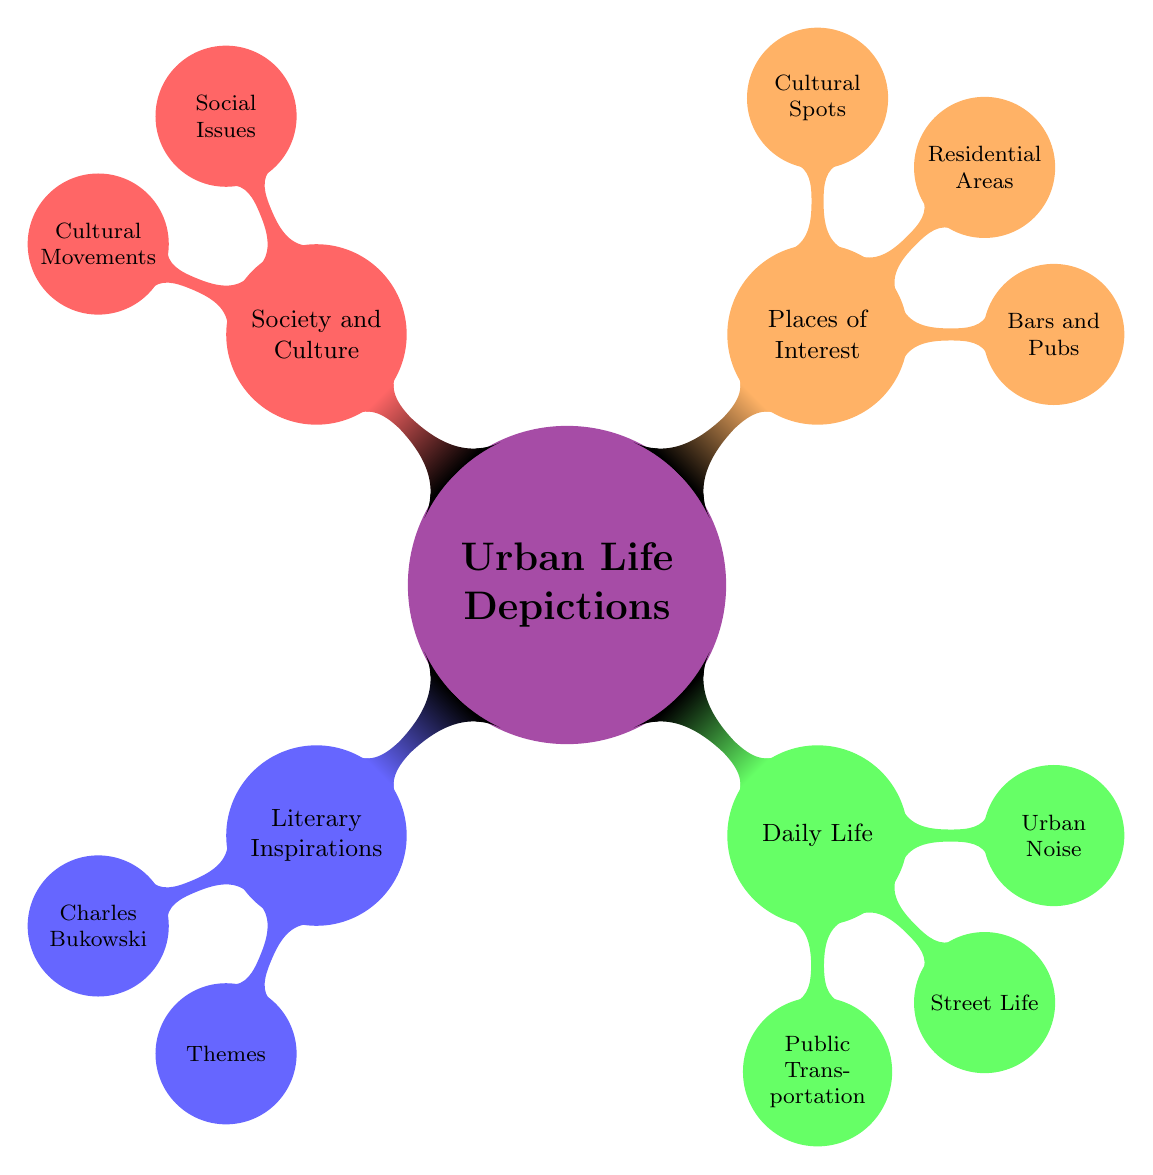What is the main theme under "Literary Inspirations"? Under "Literary Inspirations," the main theme listed is "Charles Bukowski," which indicates that he is a primary literary figure associated with urban life depictions in this diagram.
Answer: Charles Bukowski How many categories are there in the "Daily Life" section? The "Daily Life" section contains three categories: "Public Transportation," "Street Life," and "Urban Noise." Counting these gives the total number of categories.
Answer: 3 What are the three types of places listed under "Places of Interest"? The diagram specifies three types of places under "Places of Interest": "Bars and Pubs," "Residential Areas," and "Cultural Spots," which can be easily identified in the corresponding section.
Answer: Bars and Pubs, Residential Areas, Cultural Spots Which node connects themes of "Social Issues" and "Cultural Movements"? The connecting point between "Social Issues" and "Cultural Movements" is the larger category labeled "Society and Culture" in the diagram, which encompasses both nodes.
Answer: Society and Culture What type of transportation is mentioned under "Public Transportation"? The diagram lists three types of public transportation, including "Subways," which are specifically mentioned under the "Public Transportation" node.
Answer: Subways How many subcategories are found under the "Literary Inspirations" node? The "Literary Inspirations" node has two subcategories: "Charles Bukowski" and "Themes," which are clearly visible when counting the branches under that main node.
Answer: 2 Which category addresses issues of "Inequality"? The category that addresses "Inequality" is labeled "Social Issues" under the "Society and Culture" node, clearly aligning social matters with the urban experience depicted in the diagram.
Answer: Social Issues What are the three elements that describe "Street Life"? Under "Street Life," the diagram identifies three elements: "Street Vendors," "Homelessness," and "Graffiti," which are all enumerated as components of street life in an urban setting.
Answer: Street Vendors, Homelessness, Graffiti 